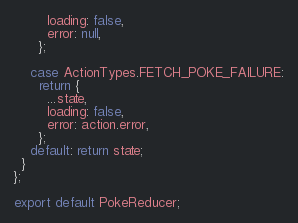<code> <loc_0><loc_0><loc_500><loc_500><_JavaScript_>        loading: false,
        error: null,
      };

    case ActionTypes.FETCH_POKE_FAILURE:
      return {
        ...state,
        loading: false,
        error: action.error,
      };
    default: return state;
  }
};

export default PokeReducer;
</code> 